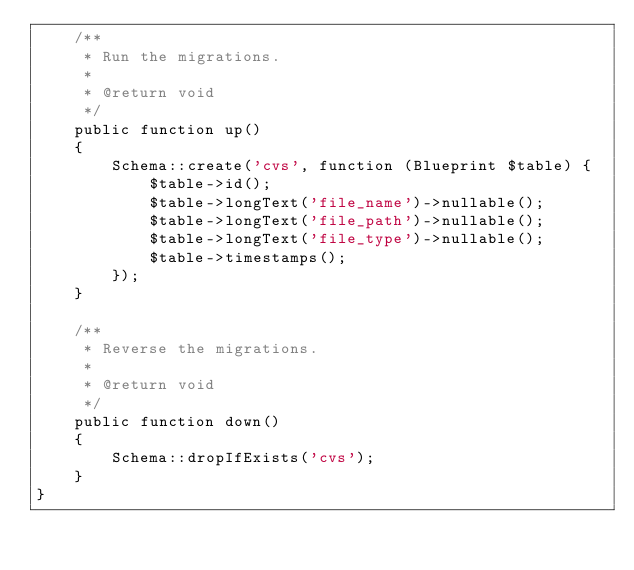<code> <loc_0><loc_0><loc_500><loc_500><_PHP_>    /**
     * Run the migrations.
     *
     * @return void
     */
    public function up()
    {
        Schema::create('cvs', function (Blueprint $table) {
            $table->id();
            $table->longText('file_name')->nullable();
            $table->longText('file_path')->nullable();
            $table->longText('file_type')->nullable();
            $table->timestamps();
        });
    }

    /**
     * Reverse the migrations.
     *
     * @return void
     */
    public function down()
    {
        Schema::dropIfExists('cvs');
    }
}
</code> 